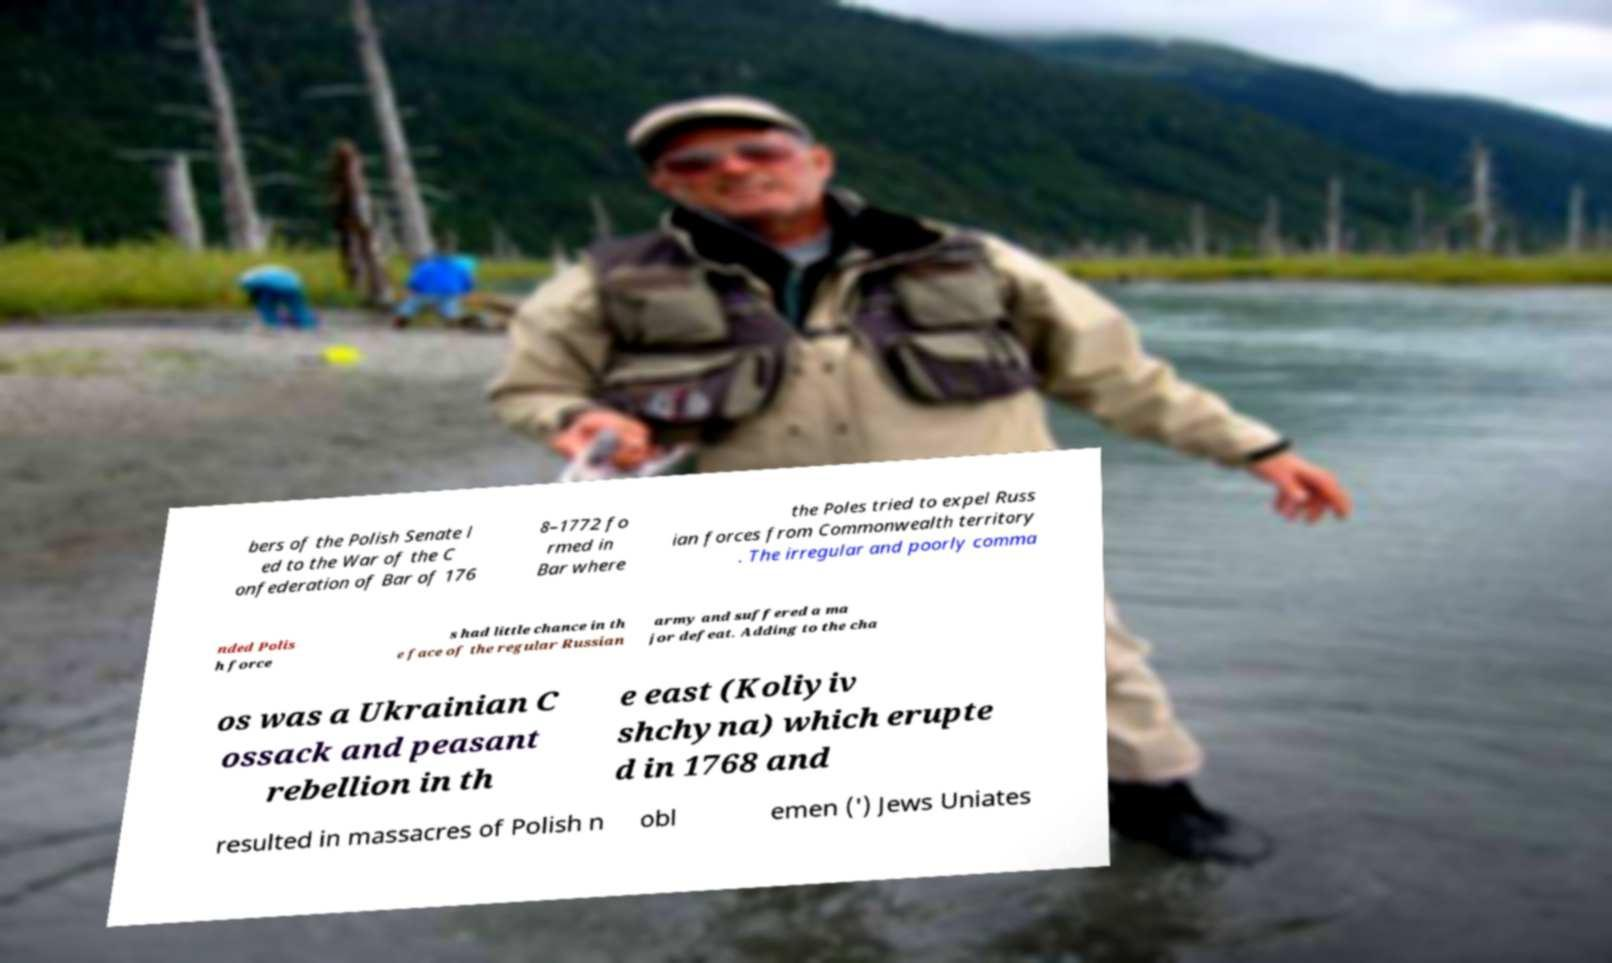Can you read and provide the text displayed in the image?This photo seems to have some interesting text. Can you extract and type it out for me? bers of the Polish Senate l ed to the War of the C onfederation of Bar of 176 8–1772 fo rmed in Bar where the Poles tried to expel Russ ian forces from Commonwealth territory . The irregular and poorly comma nded Polis h force s had little chance in th e face of the regular Russian army and suffered a ma jor defeat. Adding to the cha os was a Ukrainian C ossack and peasant rebellion in th e east (Koliyiv shchyna) which erupte d in 1768 and resulted in massacres of Polish n obl emen (') Jews Uniates 